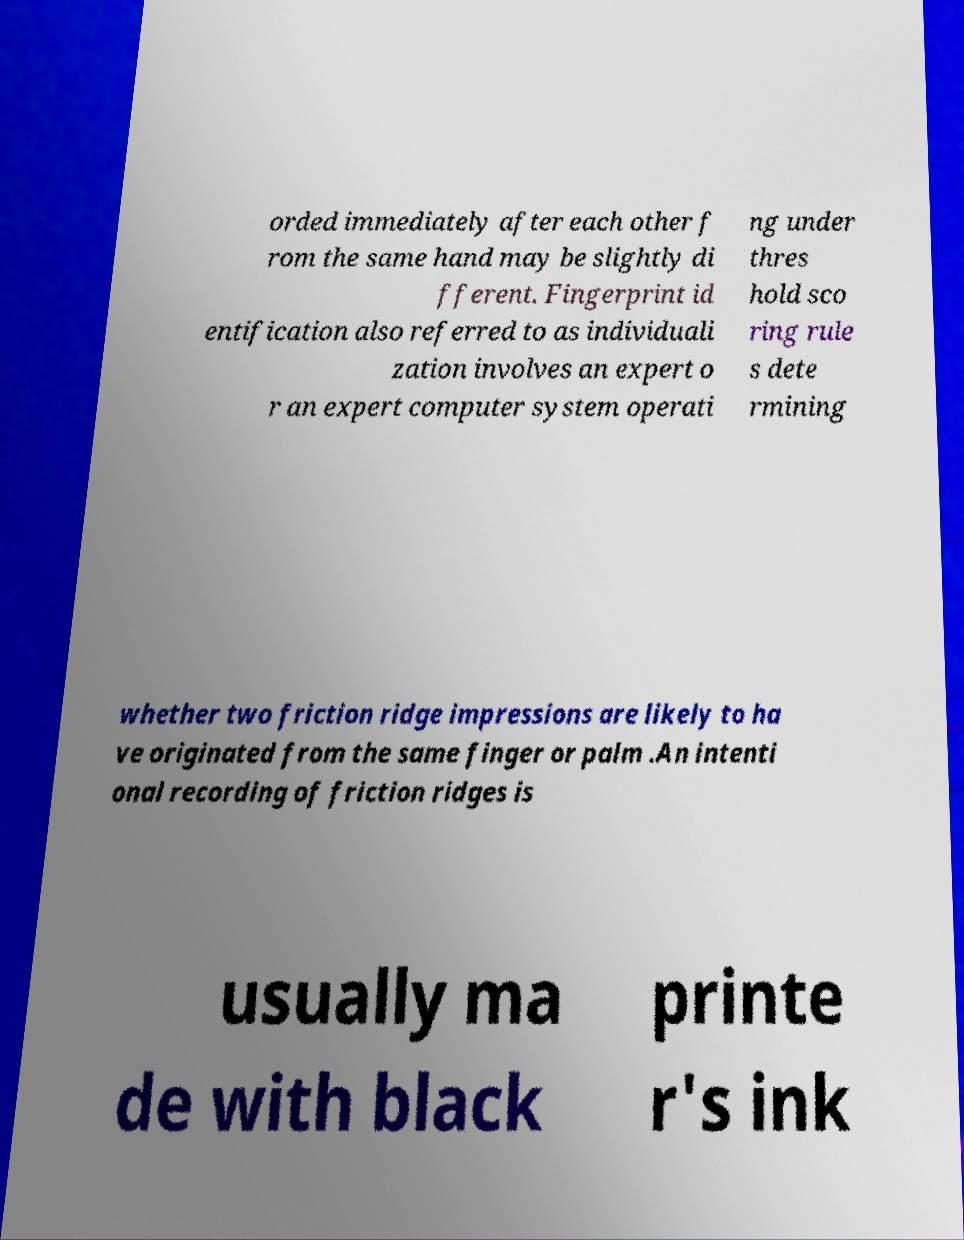Can you read and provide the text displayed in the image?This photo seems to have some interesting text. Can you extract and type it out for me? orded immediately after each other f rom the same hand may be slightly di fferent. Fingerprint id entification also referred to as individuali zation involves an expert o r an expert computer system operati ng under thres hold sco ring rule s dete rmining whether two friction ridge impressions are likely to ha ve originated from the same finger or palm .An intenti onal recording of friction ridges is usually ma de with black printe r's ink 